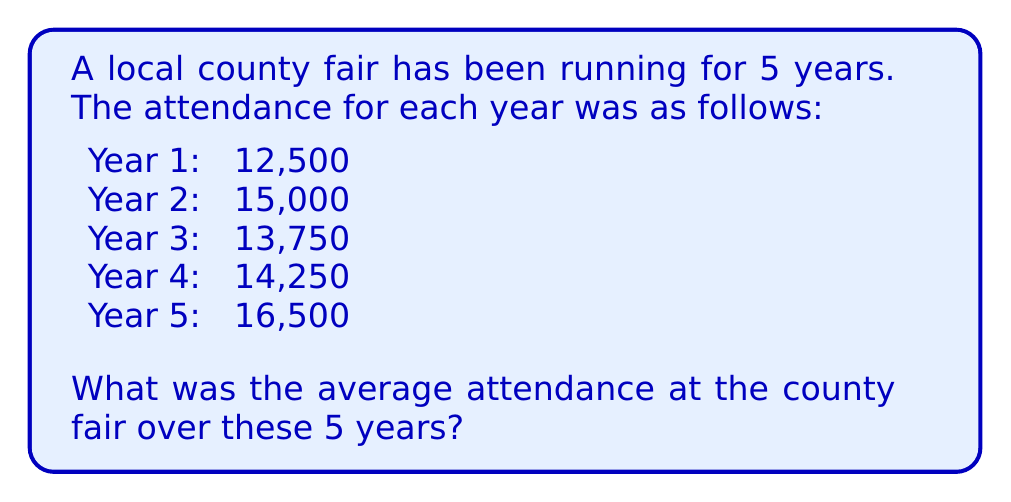Teach me how to tackle this problem. To find the average attendance, we need to:
1. Add up the total attendance for all 5 years
2. Divide the total by the number of years (5)

Step 1: Calculate the total attendance
$$\text{Total} = 12,500 + 15,000 + 13,750 + 14,250 + 16,500$$
$$\text{Total} = 72,000$$

Step 2: Calculate the average
$$\text{Average} = \frac{\text{Total attendance}}{\text{Number of years}}$$
$$\text{Average} = \frac{72,000}{5}$$
$$\text{Average} = 14,400$$

Therefore, the average attendance at the county fair over the 5 years was 14,400 people.
Answer: 14,400 people 